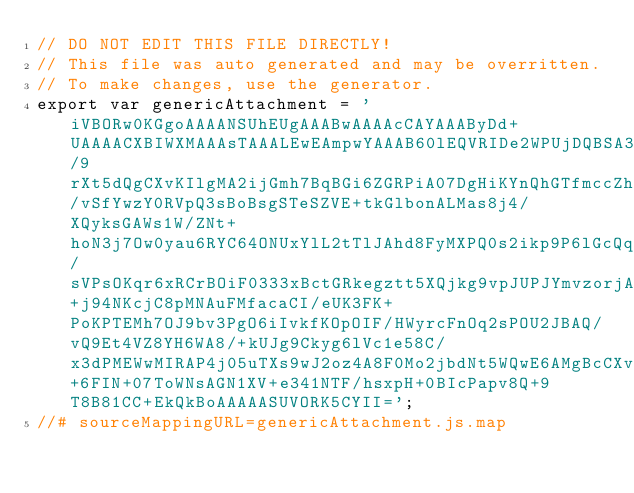<code> <loc_0><loc_0><loc_500><loc_500><_JavaScript_>// DO NOT EDIT THIS FILE DIRECTLY!
// This file was auto generated and may be overritten.
// To make changes, use the generator.
export var genericAttachment = 'iVBORw0KGgoAAAANSUhEUgAAABwAAAAcCAYAAAByDd+UAAAACXBIWXMAAAsTAAALEwEAmpwYAAAB60lEQVRIDe2WPUjDQBSA38UqdNBF3cRRugi6uOjiWEQ6ORpEN63i1A5NJWgCdrB0SJ1tOihUqQhODi5OLqIudXNwEHRysKA157uakngxVwmmkweh7/9rXt5dQgCXvKIlgMA2ijGmh7BqBGi6ZGRPiA07DgHiKYnQhGTfmccZhoECyUlYOKw2/vSfYwzY0RVpQ3sBoBsgSTeSZVE+tkGlbonALMas8j4/XQyksGAWs1W/ZNt+hoN3j7Ow0yau6RYC64ONUxYlL2tTlJAhd8FyMXPQ0s2ikp9P6lGcQq1l8/sVPsOKqr6xRCrBOiF0333xBctGRkegztt5XQjkg9vpJUPJYmvzorjAwMVUrtdbmND640jKa3csgYHvr401p4wjVSpzlqN5JeHQeMMdCxsQOalNEoBbSqhry+j94NKcjC8pMNAuFMfacaCI/eUK3FK+PoKPTEMh7OJ9bv3PgO6iIvkfKOpOIF/HWyrcFnOq2sPOU2JBAQ/vQ9Et4VZ8YH6WA8/+kUJg9Ckyg6lVc1e58C/x3dPMEWwMIRAP4j05uTXs9wJ2oz4A8F0Mo2jbdNt5WQwE6AMgBcCXvYV00RJ7ncyODw0D1hx+6FIN+07ToWNsAGN1XV+e341NTF/hsxpH+0BIcPapv8Q+9T8B81CC+EkQkBoAAAAASUVORK5CYII=';
//# sourceMappingURL=genericAttachment.js.map</code> 